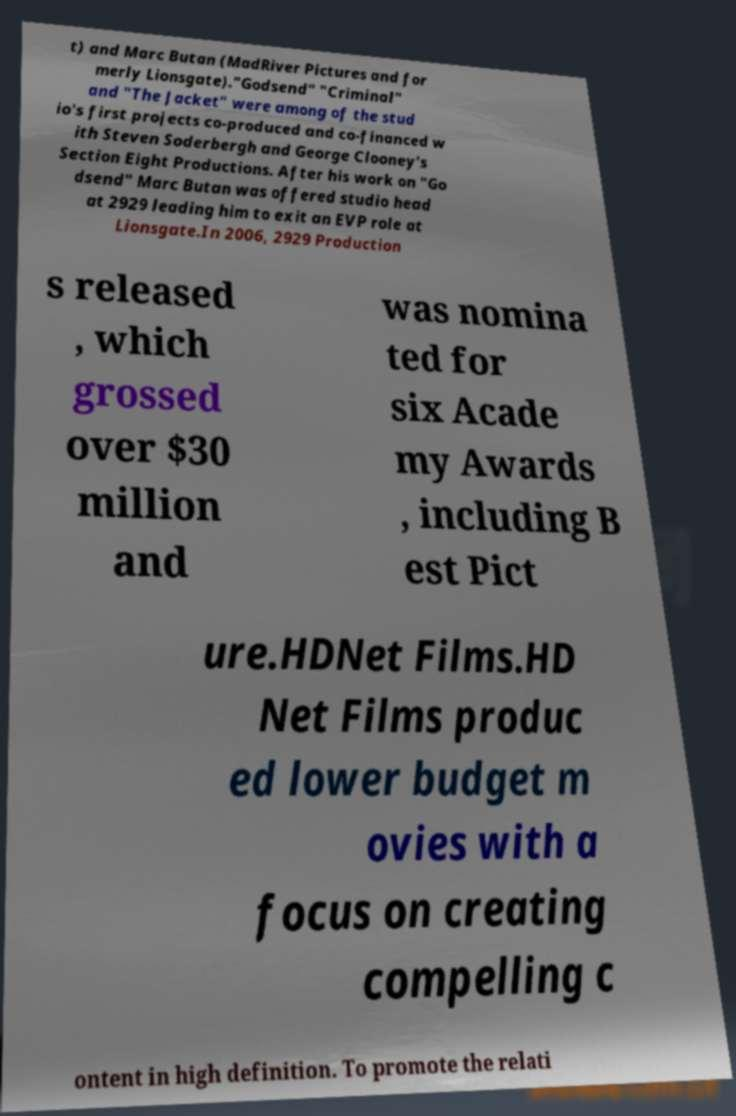Can you accurately transcribe the text from the provided image for me? t) and Marc Butan (MadRiver Pictures and for merly Lionsgate)."Godsend" "Criminal" and "The Jacket" were among of the stud io's first projects co-produced and co-financed w ith Steven Soderbergh and George Clooney's Section Eight Productions. After his work on "Go dsend" Marc Butan was offered studio head at 2929 leading him to exit an EVP role at Lionsgate.In 2006, 2929 Production s released , which grossed over $30 million and was nomina ted for six Acade my Awards , including B est Pict ure.HDNet Films.HD Net Films produc ed lower budget m ovies with a focus on creating compelling c ontent in high definition. To promote the relati 